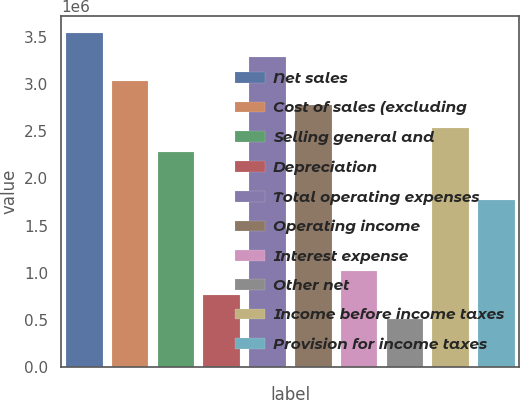Convert chart to OTSL. <chart><loc_0><loc_0><loc_500><loc_500><bar_chart><fcel>Net sales<fcel>Cost of sales (excluding<fcel>Selling general and<fcel>Depreciation<fcel>Total operating expenses<fcel>Operating income<fcel>Interest expense<fcel>Other net<fcel>Income before income taxes<fcel>Provision for income taxes<nl><fcel>3.54359e+06<fcel>3.03736e+06<fcel>2.27802e+06<fcel>759342<fcel>3.29047e+06<fcel>2.78425e+06<fcel>1.01246e+06<fcel>506229<fcel>2.53114e+06<fcel>1.7718e+06<nl></chart> 